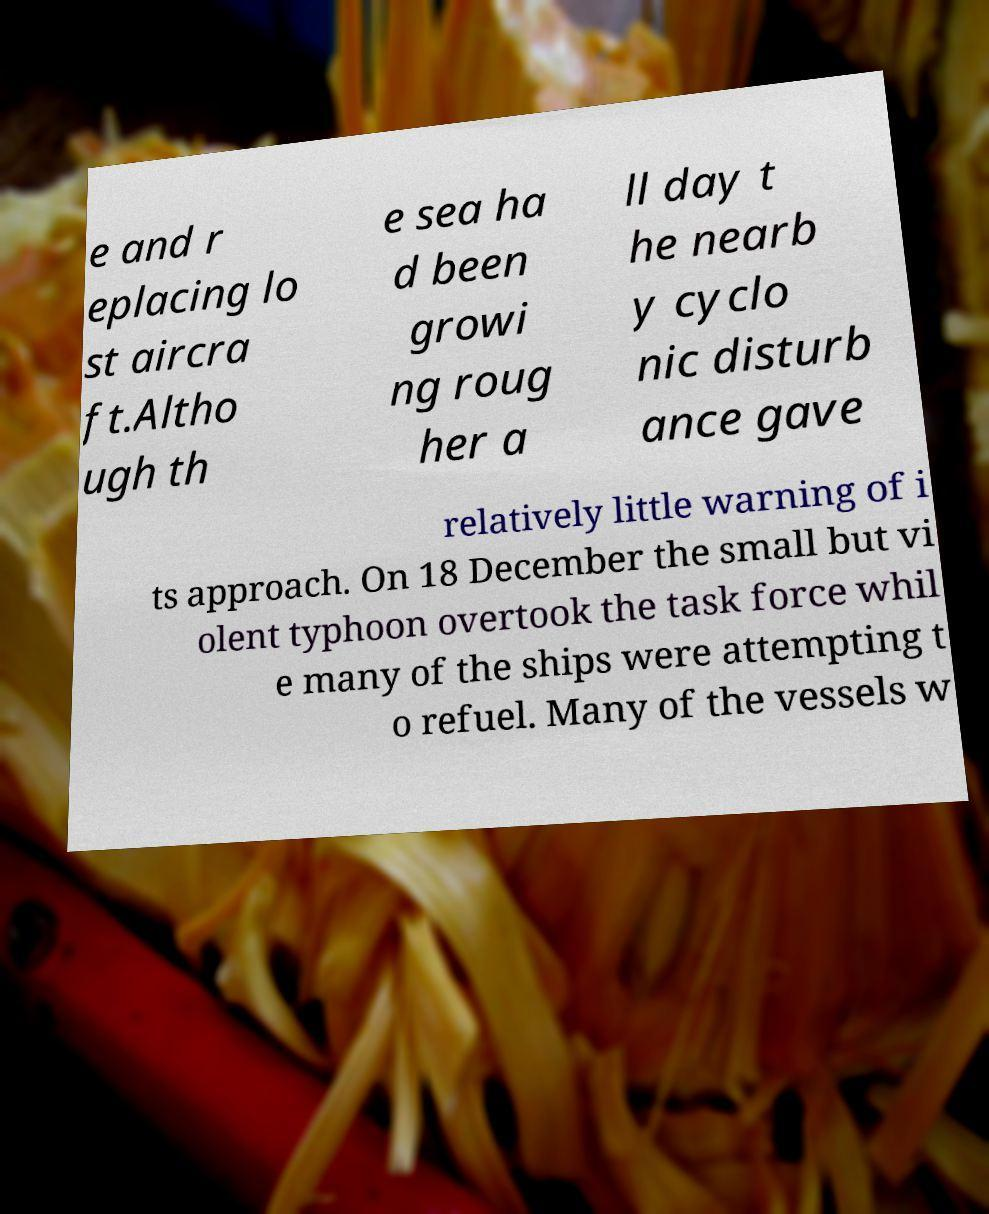What messages or text are displayed in this image? I need them in a readable, typed format. e and r eplacing lo st aircra ft.Altho ugh th e sea ha d been growi ng roug her a ll day t he nearb y cyclo nic disturb ance gave relatively little warning of i ts approach. On 18 December the small but vi olent typhoon overtook the task force whil e many of the ships were attempting t o refuel. Many of the vessels w 